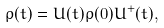<formula> <loc_0><loc_0><loc_500><loc_500>\rho ( t ) = U ( t ) \rho ( 0 ) U ^ { + } ( t ) ,</formula> 